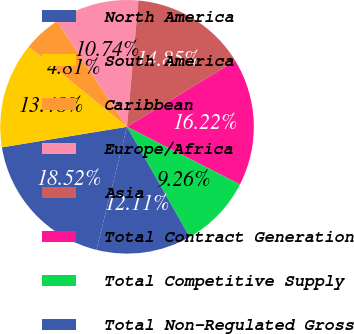Convert chart. <chart><loc_0><loc_0><loc_500><loc_500><pie_chart><fcel>North America<fcel>South America<fcel>Caribbean<fcel>Europe/Africa<fcel>Asia<fcel>Total Contract Generation<fcel>Total Competitive Supply<fcel>Total Non-Regulated Gross<nl><fcel>18.52%<fcel>13.48%<fcel>4.81%<fcel>10.74%<fcel>14.85%<fcel>16.22%<fcel>9.26%<fcel>12.11%<nl></chart> 